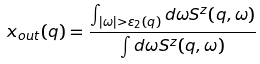<formula> <loc_0><loc_0><loc_500><loc_500>x _ { o u t } ( q ) = \frac { \int _ { | \omega | > \varepsilon _ { 2 } ( q ) } d \omega S ^ { z } ( q , \omega ) } { \int d \omega S ^ { z } ( q , \omega ) }</formula> 